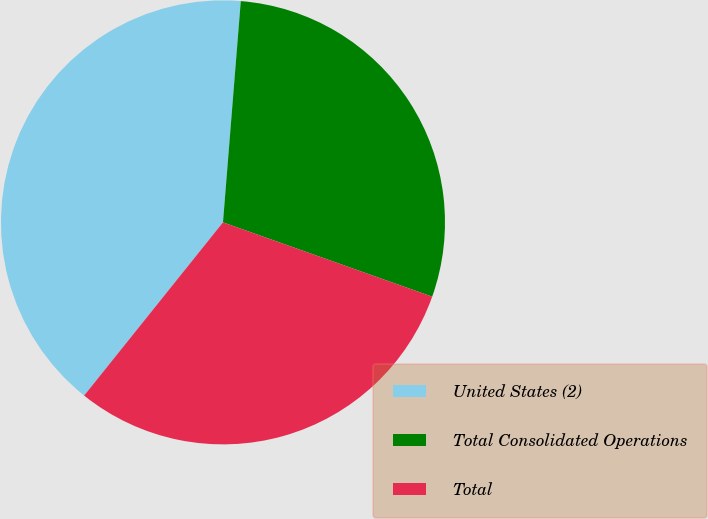<chart> <loc_0><loc_0><loc_500><loc_500><pie_chart><fcel>United States (2)<fcel>Total Consolidated Operations<fcel>Total<nl><fcel>40.52%<fcel>29.15%<fcel>30.32%<nl></chart> 